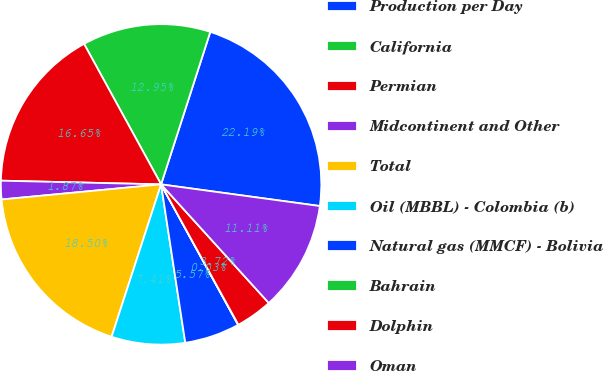Convert chart to OTSL. <chart><loc_0><loc_0><loc_500><loc_500><pie_chart><fcel>Production per Day<fcel>California<fcel>Permian<fcel>Midcontinent and Other<fcel>Total<fcel>Oil (MBBL) - Colombia (b)<fcel>Natural gas (MMCF) - Bolivia<fcel>Bahrain<fcel>Dolphin<fcel>Oman<nl><fcel>22.19%<fcel>12.95%<fcel>16.65%<fcel>1.87%<fcel>18.5%<fcel>7.41%<fcel>5.57%<fcel>0.03%<fcel>3.72%<fcel>11.11%<nl></chart> 